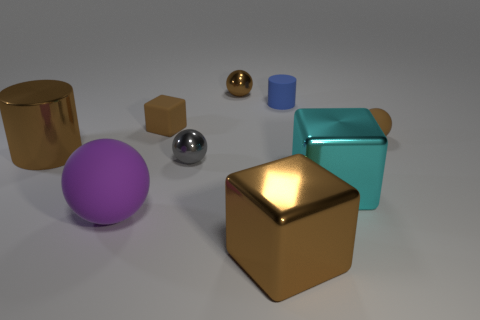Is there a brown metallic thing of the same shape as the gray metallic object?
Provide a short and direct response. Yes. What is the material of the gray sphere?
Offer a terse response. Metal. Are there any tiny brown blocks on the right side of the blue matte object?
Keep it short and to the point. No. Does the big purple thing have the same shape as the blue matte object?
Offer a very short reply. No. How many other objects are the same size as the brown matte cube?
Ensure brevity in your answer.  4. How many things are large cubes left of the small blue object or rubber cylinders?
Provide a short and direct response. 2. The small matte cube has what color?
Keep it short and to the point. Brown. What is the material of the big cube that is on the left side of the cyan shiny thing?
Ensure brevity in your answer.  Metal. There is a large cyan thing; is it the same shape as the metal object that is in front of the big cyan thing?
Offer a terse response. Yes. Are there more blue matte cylinders than purple metal blocks?
Your response must be concise. Yes. 